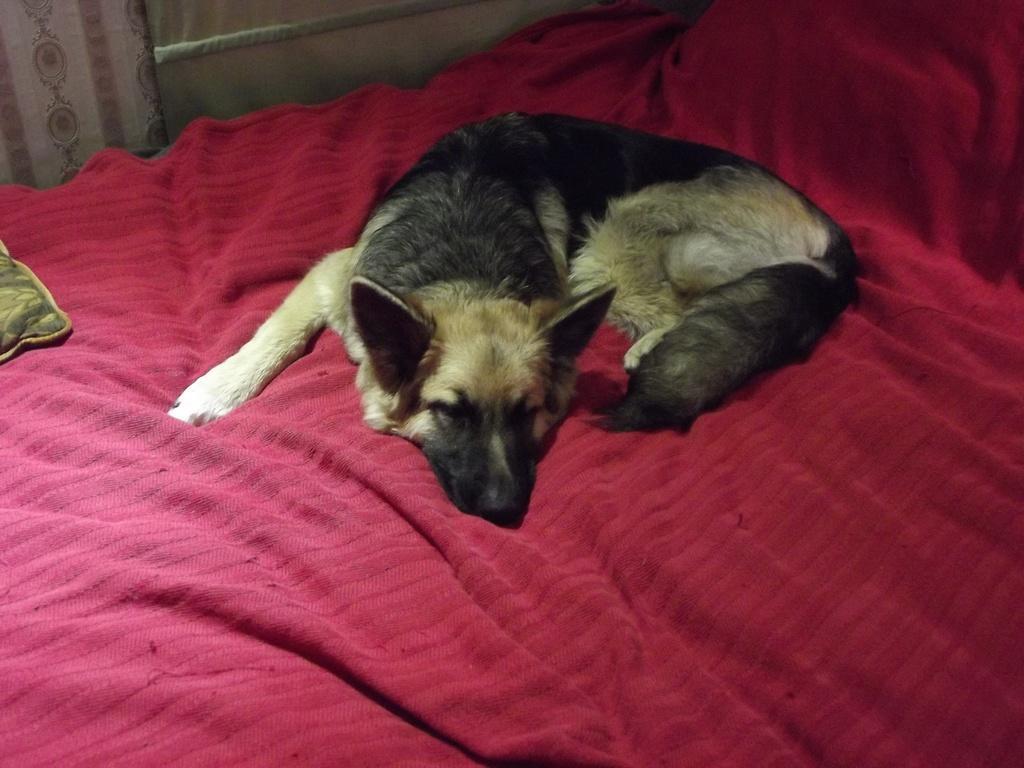Can you describe this image briefly? In this picture we can observe a dog which is in black and brown color laying on the bed. There is a red color bed sheet. On the left side we can observe a curtain. 